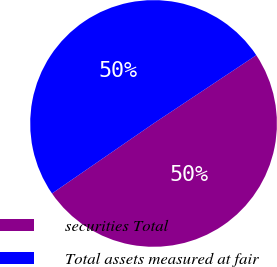<chart> <loc_0><loc_0><loc_500><loc_500><pie_chart><fcel>securities Total<fcel>Total assets measured at fair<nl><fcel>49.73%<fcel>50.27%<nl></chart> 